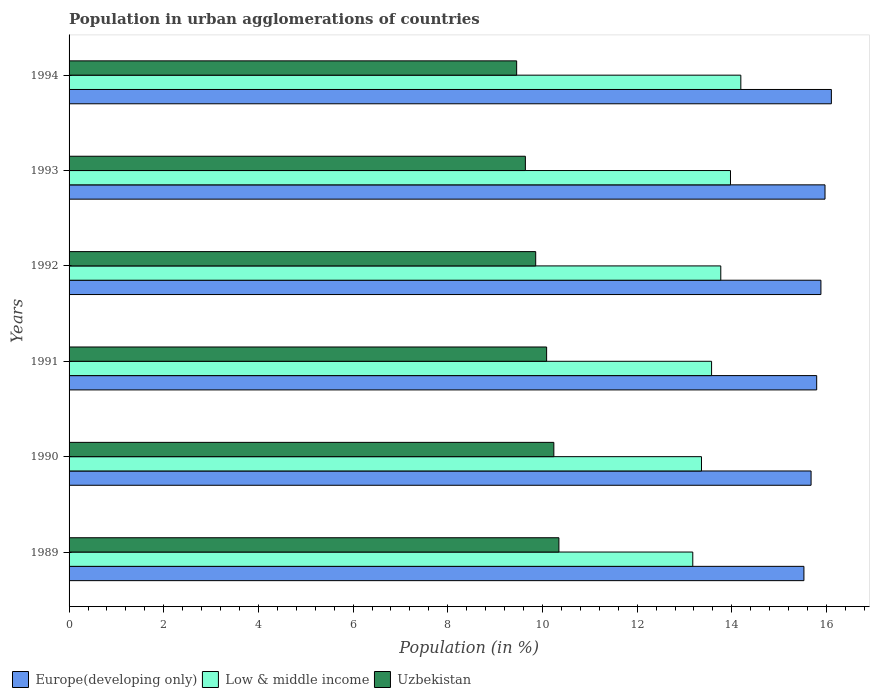How many groups of bars are there?
Your answer should be compact. 6. Are the number of bars on each tick of the Y-axis equal?
Offer a terse response. Yes. How many bars are there on the 6th tick from the top?
Offer a very short reply. 3. What is the label of the 4th group of bars from the top?
Offer a terse response. 1991. In how many cases, is the number of bars for a given year not equal to the number of legend labels?
Your answer should be very brief. 0. What is the percentage of population in urban agglomerations in Uzbekistan in 1992?
Offer a terse response. 9.86. Across all years, what is the maximum percentage of population in urban agglomerations in Low & middle income?
Offer a very short reply. 14.19. Across all years, what is the minimum percentage of population in urban agglomerations in Uzbekistan?
Ensure brevity in your answer.  9.46. In which year was the percentage of population in urban agglomerations in Europe(developing only) minimum?
Your answer should be compact. 1989. What is the total percentage of population in urban agglomerations in Uzbekistan in the graph?
Keep it short and to the point. 59.63. What is the difference between the percentage of population in urban agglomerations in Europe(developing only) in 1989 and that in 1991?
Provide a short and direct response. -0.27. What is the difference between the percentage of population in urban agglomerations in Low & middle income in 1993 and the percentage of population in urban agglomerations in Europe(developing only) in 1994?
Your answer should be very brief. -2.13. What is the average percentage of population in urban agglomerations in Low & middle income per year?
Your response must be concise. 13.67. In the year 1993, what is the difference between the percentage of population in urban agglomerations in Europe(developing only) and percentage of population in urban agglomerations in Uzbekistan?
Provide a succinct answer. 6.33. What is the ratio of the percentage of population in urban agglomerations in Europe(developing only) in 1989 to that in 1991?
Your answer should be compact. 0.98. Is the difference between the percentage of population in urban agglomerations in Europe(developing only) in 1991 and 1993 greater than the difference between the percentage of population in urban agglomerations in Uzbekistan in 1991 and 1993?
Your answer should be very brief. No. What is the difference between the highest and the second highest percentage of population in urban agglomerations in Uzbekistan?
Make the answer very short. 0.11. What is the difference between the highest and the lowest percentage of population in urban agglomerations in Uzbekistan?
Offer a terse response. 0.89. What does the 3rd bar from the top in 1993 represents?
Offer a very short reply. Europe(developing only). What does the 1st bar from the bottom in 1990 represents?
Provide a short and direct response. Europe(developing only). How many bars are there?
Provide a short and direct response. 18. Are all the bars in the graph horizontal?
Your response must be concise. Yes. How many years are there in the graph?
Provide a short and direct response. 6. What is the difference between two consecutive major ticks on the X-axis?
Offer a very short reply. 2. Are the values on the major ticks of X-axis written in scientific E-notation?
Offer a terse response. No. Does the graph contain any zero values?
Your response must be concise. No. How many legend labels are there?
Your answer should be compact. 3. How are the legend labels stacked?
Offer a terse response. Horizontal. What is the title of the graph?
Keep it short and to the point. Population in urban agglomerations of countries. Does "Sao Tome and Principe" appear as one of the legend labels in the graph?
Make the answer very short. No. What is the label or title of the X-axis?
Make the answer very short. Population (in %). What is the Population (in %) in Europe(developing only) in 1989?
Provide a short and direct response. 15.52. What is the Population (in %) of Low & middle income in 1989?
Offer a very short reply. 13.18. What is the Population (in %) in Uzbekistan in 1989?
Give a very brief answer. 10.35. What is the Population (in %) of Europe(developing only) in 1990?
Your response must be concise. 15.67. What is the Population (in %) in Low & middle income in 1990?
Give a very brief answer. 13.36. What is the Population (in %) in Uzbekistan in 1990?
Provide a short and direct response. 10.24. What is the Population (in %) of Europe(developing only) in 1991?
Offer a very short reply. 15.79. What is the Population (in %) in Low & middle income in 1991?
Give a very brief answer. 13.57. What is the Population (in %) of Uzbekistan in 1991?
Provide a short and direct response. 10.09. What is the Population (in %) of Europe(developing only) in 1992?
Offer a terse response. 15.88. What is the Population (in %) of Low & middle income in 1992?
Your answer should be very brief. 13.77. What is the Population (in %) in Uzbekistan in 1992?
Your answer should be compact. 9.86. What is the Population (in %) of Europe(developing only) in 1993?
Your response must be concise. 15.97. What is the Population (in %) of Low & middle income in 1993?
Give a very brief answer. 13.97. What is the Population (in %) of Uzbekistan in 1993?
Provide a short and direct response. 9.64. What is the Population (in %) in Europe(developing only) in 1994?
Ensure brevity in your answer.  16.1. What is the Population (in %) of Low & middle income in 1994?
Your answer should be very brief. 14.19. What is the Population (in %) of Uzbekistan in 1994?
Your answer should be compact. 9.46. Across all years, what is the maximum Population (in %) of Europe(developing only)?
Offer a very short reply. 16.1. Across all years, what is the maximum Population (in %) in Low & middle income?
Provide a succinct answer. 14.19. Across all years, what is the maximum Population (in %) of Uzbekistan?
Make the answer very short. 10.35. Across all years, what is the minimum Population (in %) of Europe(developing only)?
Offer a terse response. 15.52. Across all years, what is the minimum Population (in %) of Low & middle income?
Ensure brevity in your answer.  13.18. Across all years, what is the minimum Population (in %) of Uzbekistan?
Your response must be concise. 9.46. What is the total Population (in %) in Europe(developing only) in the graph?
Provide a short and direct response. 94.95. What is the total Population (in %) of Low & middle income in the graph?
Give a very brief answer. 82.04. What is the total Population (in %) in Uzbekistan in the graph?
Offer a terse response. 59.63. What is the difference between the Population (in %) of Europe(developing only) in 1989 and that in 1990?
Provide a short and direct response. -0.15. What is the difference between the Population (in %) of Low & middle income in 1989 and that in 1990?
Make the answer very short. -0.18. What is the difference between the Population (in %) of Uzbekistan in 1989 and that in 1990?
Provide a succinct answer. 0.11. What is the difference between the Population (in %) in Europe(developing only) in 1989 and that in 1991?
Your response must be concise. -0.27. What is the difference between the Population (in %) of Low & middle income in 1989 and that in 1991?
Ensure brevity in your answer.  -0.4. What is the difference between the Population (in %) of Uzbekistan in 1989 and that in 1991?
Offer a terse response. 0.26. What is the difference between the Population (in %) of Europe(developing only) in 1989 and that in 1992?
Provide a short and direct response. -0.36. What is the difference between the Population (in %) of Low & middle income in 1989 and that in 1992?
Offer a terse response. -0.59. What is the difference between the Population (in %) in Uzbekistan in 1989 and that in 1992?
Your answer should be compact. 0.49. What is the difference between the Population (in %) of Europe(developing only) in 1989 and that in 1993?
Give a very brief answer. -0.45. What is the difference between the Population (in %) of Low & middle income in 1989 and that in 1993?
Give a very brief answer. -0.8. What is the difference between the Population (in %) in Uzbekistan in 1989 and that in 1993?
Your answer should be very brief. 0.71. What is the difference between the Population (in %) of Europe(developing only) in 1989 and that in 1994?
Your response must be concise. -0.58. What is the difference between the Population (in %) in Low & middle income in 1989 and that in 1994?
Offer a terse response. -1.01. What is the difference between the Population (in %) in Uzbekistan in 1989 and that in 1994?
Keep it short and to the point. 0.89. What is the difference between the Population (in %) in Europe(developing only) in 1990 and that in 1991?
Give a very brief answer. -0.12. What is the difference between the Population (in %) in Low & middle income in 1990 and that in 1991?
Offer a very short reply. -0.21. What is the difference between the Population (in %) in Uzbekistan in 1990 and that in 1991?
Make the answer very short. 0.15. What is the difference between the Population (in %) of Europe(developing only) in 1990 and that in 1992?
Keep it short and to the point. -0.21. What is the difference between the Population (in %) of Low & middle income in 1990 and that in 1992?
Your answer should be compact. -0.41. What is the difference between the Population (in %) in Uzbekistan in 1990 and that in 1992?
Your answer should be compact. 0.38. What is the difference between the Population (in %) in Europe(developing only) in 1990 and that in 1993?
Your answer should be compact. -0.29. What is the difference between the Population (in %) of Low & middle income in 1990 and that in 1993?
Give a very brief answer. -0.61. What is the difference between the Population (in %) in Uzbekistan in 1990 and that in 1993?
Offer a very short reply. 0.6. What is the difference between the Population (in %) in Europe(developing only) in 1990 and that in 1994?
Your answer should be very brief. -0.43. What is the difference between the Population (in %) in Low & middle income in 1990 and that in 1994?
Your answer should be very brief. -0.83. What is the difference between the Population (in %) of Uzbekistan in 1990 and that in 1994?
Your answer should be compact. 0.79. What is the difference between the Population (in %) in Europe(developing only) in 1991 and that in 1992?
Offer a very short reply. -0.09. What is the difference between the Population (in %) in Low & middle income in 1991 and that in 1992?
Ensure brevity in your answer.  -0.19. What is the difference between the Population (in %) in Uzbekistan in 1991 and that in 1992?
Keep it short and to the point. 0.23. What is the difference between the Population (in %) of Europe(developing only) in 1991 and that in 1993?
Keep it short and to the point. -0.18. What is the difference between the Population (in %) of Low & middle income in 1991 and that in 1993?
Provide a succinct answer. -0.4. What is the difference between the Population (in %) of Uzbekistan in 1991 and that in 1993?
Keep it short and to the point. 0.45. What is the difference between the Population (in %) in Europe(developing only) in 1991 and that in 1994?
Your answer should be compact. -0.31. What is the difference between the Population (in %) of Low & middle income in 1991 and that in 1994?
Provide a succinct answer. -0.62. What is the difference between the Population (in %) of Uzbekistan in 1991 and that in 1994?
Make the answer very short. 0.63. What is the difference between the Population (in %) of Europe(developing only) in 1992 and that in 1993?
Give a very brief answer. -0.09. What is the difference between the Population (in %) in Low & middle income in 1992 and that in 1993?
Provide a short and direct response. -0.2. What is the difference between the Population (in %) of Uzbekistan in 1992 and that in 1993?
Offer a very short reply. 0.22. What is the difference between the Population (in %) in Europe(developing only) in 1992 and that in 1994?
Keep it short and to the point. -0.22. What is the difference between the Population (in %) in Low & middle income in 1992 and that in 1994?
Offer a terse response. -0.42. What is the difference between the Population (in %) of Uzbekistan in 1992 and that in 1994?
Your answer should be very brief. 0.4. What is the difference between the Population (in %) in Europe(developing only) in 1993 and that in 1994?
Offer a very short reply. -0.13. What is the difference between the Population (in %) of Low & middle income in 1993 and that in 1994?
Offer a terse response. -0.22. What is the difference between the Population (in %) in Uzbekistan in 1993 and that in 1994?
Provide a succinct answer. 0.18. What is the difference between the Population (in %) in Europe(developing only) in 1989 and the Population (in %) in Low & middle income in 1990?
Provide a succinct answer. 2.16. What is the difference between the Population (in %) in Europe(developing only) in 1989 and the Population (in %) in Uzbekistan in 1990?
Keep it short and to the point. 5.28. What is the difference between the Population (in %) in Low & middle income in 1989 and the Population (in %) in Uzbekistan in 1990?
Your answer should be very brief. 2.94. What is the difference between the Population (in %) of Europe(developing only) in 1989 and the Population (in %) of Low & middle income in 1991?
Give a very brief answer. 1.95. What is the difference between the Population (in %) in Europe(developing only) in 1989 and the Population (in %) in Uzbekistan in 1991?
Provide a succinct answer. 5.44. What is the difference between the Population (in %) in Low & middle income in 1989 and the Population (in %) in Uzbekistan in 1991?
Offer a terse response. 3.09. What is the difference between the Population (in %) of Europe(developing only) in 1989 and the Population (in %) of Low & middle income in 1992?
Provide a short and direct response. 1.76. What is the difference between the Population (in %) in Europe(developing only) in 1989 and the Population (in %) in Uzbekistan in 1992?
Give a very brief answer. 5.67. What is the difference between the Population (in %) of Low & middle income in 1989 and the Population (in %) of Uzbekistan in 1992?
Keep it short and to the point. 3.32. What is the difference between the Population (in %) of Europe(developing only) in 1989 and the Population (in %) of Low & middle income in 1993?
Keep it short and to the point. 1.55. What is the difference between the Population (in %) in Europe(developing only) in 1989 and the Population (in %) in Uzbekistan in 1993?
Provide a short and direct response. 5.88. What is the difference between the Population (in %) of Low & middle income in 1989 and the Population (in %) of Uzbekistan in 1993?
Your answer should be very brief. 3.54. What is the difference between the Population (in %) of Europe(developing only) in 1989 and the Population (in %) of Low & middle income in 1994?
Your answer should be compact. 1.33. What is the difference between the Population (in %) in Europe(developing only) in 1989 and the Population (in %) in Uzbekistan in 1994?
Make the answer very short. 6.07. What is the difference between the Population (in %) of Low & middle income in 1989 and the Population (in %) of Uzbekistan in 1994?
Your response must be concise. 3.72. What is the difference between the Population (in %) in Europe(developing only) in 1990 and the Population (in %) in Low & middle income in 1991?
Provide a short and direct response. 2.1. What is the difference between the Population (in %) in Europe(developing only) in 1990 and the Population (in %) in Uzbekistan in 1991?
Offer a very short reply. 5.59. What is the difference between the Population (in %) of Low & middle income in 1990 and the Population (in %) of Uzbekistan in 1991?
Provide a succinct answer. 3.27. What is the difference between the Population (in %) in Europe(developing only) in 1990 and the Population (in %) in Low & middle income in 1992?
Your answer should be very brief. 1.91. What is the difference between the Population (in %) in Europe(developing only) in 1990 and the Population (in %) in Uzbekistan in 1992?
Offer a very short reply. 5.82. What is the difference between the Population (in %) in Low & middle income in 1990 and the Population (in %) in Uzbekistan in 1992?
Provide a succinct answer. 3.5. What is the difference between the Population (in %) in Europe(developing only) in 1990 and the Population (in %) in Low & middle income in 1993?
Keep it short and to the point. 1.7. What is the difference between the Population (in %) in Europe(developing only) in 1990 and the Population (in %) in Uzbekistan in 1993?
Give a very brief answer. 6.04. What is the difference between the Population (in %) of Low & middle income in 1990 and the Population (in %) of Uzbekistan in 1993?
Ensure brevity in your answer.  3.72. What is the difference between the Population (in %) in Europe(developing only) in 1990 and the Population (in %) in Low & middle income in 1994?
Give a very brief answer. 1.48. What is the difference between the Population (in %) in Europe(developing only) in 1990 and the Population (in %) in Uzbekistan in 1994?
Offer a terse response. 6.22. What is the difference between the Population (in %) in Low & middle income in 1990 and the Population (in %) in Uzbekistan in 1994?
Offer a very short reply. 3.9. What is the difference between the Population (in %) of Europe(developing only) in 1991 and the Population (in %) of Low & middle income in 1992?
Provide a short and direct response. 2.03. What is the difference between the Population (in %) of Europe(developing only) in 1991 and the Population (in %) of Uzbekistan in 1992?
Give a very brief answer. 5.94. What is the difference between the Population (in %) in Low & middle income in 1991 and the Population (in %) in Uzbekistan in 1992?
Ensure brevity in your answer.  3.72. What is the difference between the Population (in %) of Europe(developing only) in 1991 and the Population (in %) of Low & middle income in 1993?
Ensure brevity in your answer.  1.82. What is the difference between the Population (in %) in Europe(developing only) in 1991 and the Population (in %) in Uzbekistan in 1993?
Ensure brevity in your answer.  6.15. What is the difference between the Population (in %) of Low & middle income in 1991 and the Population (in %) of Uzbekistan in 1993?
Your response must be concise. 3.93. What is the difference between the Population (in %) of Europe(developing only) in 1991 and the Population (in %) of Low & middle income in 1994?
Ensure brevity in your answer.  1.6. What is the difference between the Population (in %) in Europe(developing only) in 1991 and the Population (in %) in Uzbekistan in 1994?
Provide a short and direct response. 6.34. What is the difference between the Population (in %) of Low & middle income in 1991 and the Population (in %) of Uzbekistan in 1994?
Ensure brevity in your answer.  4.12. What is the difference between the Population (in %) in Europe(developing only) in 1992 and the Population (in %) in Low & middle income in 1993?
Give a very brief answer. 1.91. What is the difference between the Population (in %) of Europe(developing only) in 1992 and the Population (in %) of Uzbekistan in 1993?
Your answer should be compact. 6.24. What is the difference between the Population (in %) of Low & middle income in 1992 and the Population (in %) of Uzbekistan in 1993?
Your response must be concise. 4.13. What is the difference between the Population (in %) of Europe(developing only) in 1992 and the Population (in %) of Low & middle income in 1994?
Make the answer very short. 1.69. What is the difference between the Population (in %) of Europe(developing only) in 1992 and the Population (in %) of Uzbekistan in 1994?
Offer a terse response. 6.43. What is the difference between the Population (in %) of Low & middle income in 1992 and the Population (in %) of Uzbekistan in 1994?
Provide a succinct answer. 4.31. What is the difference between the Population (in %) of Europe(developing only) in 1993 and the Population (in %) of Low & middle income in 1994?
Offer a terse response. 1.78. What is the difference between the Population (in %) in Europe(developing only) in 1993 and the Population (in %) in Uzbekistan in 1994?
Keep it short and to the point. 6.51. What is the difference between the Population (in %) in Low & middle income in 1993 and the Population (in %) in Uzbekistan in 1994?
Ensure brevity in your answer.  4.52. What is the average Population (in %) of Europe(developing only) per year?
Provide a short and direct response. 15.82. What is the average Population (in %) in Low & middle income per year?
Offer a very short reply. 13.67. What is the average Population (in %) in Uzbekistan per year?
Give a very brief answer. 9.94. In the year 1989, what is the difference between the Population (in %) of Europe(developing only) and Population (in %) of Low & middle income?
Your response must be concise. 2.35. In the year 1989, what is the difference between the Population (in %) in Europe(developing only) and Population (in %) in Uzbekistan?
Make the answer very short. 5.18. In the year 1989, what is the difference between the Population (in %) in Low & middle income and Population (in %) in Uzbekistan?
Provide a succinct answer. 2.83. In the year 1990, what is the difference between the Population (in %) in Europe(developing only) and Population (in %) in Low & middle income?
Keep it short and to the point. 2.32. In the year 1990, what is the difference between the Population (in %) in Europe(developing only) and Population (in %) in Uzbekistan?
Give a very brief answer. 5.43. In the year 1990, what is the difference between the Population (in %) of Low & middle income and Population (in %) of Uzbekistan?
Your response must be concise. 3.12. In the year 1991, what is the difference between the Population (in %) of Europe(developing only) and Population (in %) of Low & middle income?
Your answer should be compact. 2.22. In the year 1991, what is the difference between the Population (in %) of Europe(developing only) and Population (in %) of Uzbekistan?
Provide a short and direct response. 5.71. In the year 1991, what is the difference between the Population (in %) in Low & middle income and Population (in %) in Uzbekistan?
Your answer should be very brief. 3.48. In the year 1992, what is the difference between the Population (in %) in Europe(developing only) and Population (in %) in Low & middle income?
Offer a terse response. 2.12. In the year 1992, what is the difference between the Population (in %) of Europe(developing only) and Population (in %) of Uzbekistan?
Provide a short and direct response. 6.03. In the year 1992, what is the difference between the Population (in %) in Low & middle income and Population (in %) in Uzbekistan?
Provide a succinct answer. 3.91. In the year 1993, what is the difference between the Population (in %) of Europe(developing only) and Population (in %) of Low & middle income?
Your answer should be compact. 2. In the year 1993, what is the difference between the Population (in %) of Europe(developing only) and Population (in %) of Uzbekistan?
Give a very brief answer. 6.33. In the year 1993, what is the difference between the Population (in %) of Low & middle income and Population (in %) of Uzbekistan?
Offer a very short reply. 4.33. In the year 1994, what is the difference between the Population (in %) in Europe(developing only) and Population (in %) in Low & middle income?
Your answer should be compact. 1.91. In the year 1994, what is the difference between the Population (in %) of Europe(developing only) and Population (in %) of Uzbekistan?
Provide a short and direct response. 6.65. In the year 1994, what is the difference between the Population (in %) of Low & middle income and Population (in %) of Uzbekistan?
Provide a short and direct response. 4.74. What is the ratio of the Population (in %) of Low & middle income in 1989 to that in 1990?
Make the answer very short. 0.99. What is the ratio of the Population (in %) of Uzbekistan in 1989 to that in 1990?
Make the answer very short. 1.01. What is the ratio of the Population (in %) of Europe(developing only) in 1989 to that in 1991?
Make the answer very short. 0.98. What is the ratio of the Population (in %) in Low & middle income in 1989 to that in 1991?
Ensure brevity in your answer.  0.97. What is the ratio of the Population (in %) of Uzbekistan in 1989 to that in 1991?
Provide a short and direct response. 1.03. What is the ratio of the Population (in %) in Europe(developing only) in 1989 to that in 1992?
Your answer should be compact. 0.98. What is the ratio of the Population (in %) of Uzbekistan in 1989 to that in 1992?
Provide a short and direct response. 1.05. What is the ratio of the Population (in %) of Europe(developing only) in 1989 to that in 1993?
Provide a succinct answer. 0.97. What is the ratio of the Population (in %) in Low & middle income in 1989 to that in 1993?
Make the answer very short. 0.94. What is the ratio of the Population (in %) of Uzbekistan in 1989 to that in 1993?
Give a very brief answer. 1.07. What is the ratio of the Population (in %) of Low & middle income in 1989 to that in 1994?
Provide a short and direct response. 0.93. What is the ratio of the Population (in %) of Uzbekistan in 1989 to that in 1994?
Your answer should be very brief. 1.09. What is the ratio of the Population (in %) of Europe(developing only) in 1990 to that in 1991?
Keep it short and to the point. 0.99. What is the ratio of the Population (in %) of Low & middle income in 1990 to that in 1991?
Ensure brevity in your answer.  0.98. What is the ratio of the Population (in %) of Uzbekistan in 1990 to that in 1991?
Make the answer very short. 1.02. What is the ratio of the Population (in %) in Europe(developing only) in 1990 to that in 1992?
Keep it short and to the point. 0.99. What is the ratio of the Population (in %) in Low & middle income in 1990 to that in 1992?
Ensure brevity in your answer.  0.97. What is the ratio of the Population (in %) of Uzbekistan in 1990 to that in 1992?
Ensure brevity in your answer.  1.04. What is the ratio of the Population (in %) of Europe(developing only) in 1990 to that in 1993?
Make the answer very short. 0.98. What is the ratio of the Population (in %) in Low & middle income in 1990 to that in 1993?
Provide a succinct answer. 0.96. What is the ratio of the Population (in %) of Uzbekistan in 1990 to that in 1993?
Offer a very short reply. 1.06. What is the ratio of the Population (in %) in Europe(developing only) in 1990 to that in 1994?
Your answer should be compact. 0.97. What is the ratio of the Population (in %) in Low & middle income in 1990 to that in 1994?
Your answer should be very brief. 0.94. What is the ratio of the Population (in %) of Uzbekistan in 1990 to that in 1994?
Offer a terse response. 1.08. What is the ratio of the Population (in %) of Low & middle income in 1991 to that in 1992?
Make the answer very short. 0.99. What is the ratio of the Population (in %) in Uzbekistan in 1991 to that in 1992?
Keep it short and to the point. 1.02. What is the ratio of the Population (in %) in Low & middle income in 1991 to that in 1993?
Your answer should be very brief. 0.97. What is the ratio of the Population (in %) in Uzbekistan in 1991 to that in 1993?
Make the answer very short. 1.05. What is the ratio of the Population (in %) in Europe(developing only) in 1991 to that in 1994?
Your answer should be very brief. 0.98. What is the ratio of the Population (in %) of Low & middle income in 1991 to that in 1994?
Offer a very short reply. 0.96. What is the ratio of the Population (in %) of Uzbekistan in 1991 to that in 1994?
Your answer should be compact. 1.07. What is the ratio of the Population (in %) in Uzbekistan in 1992 to that in 1993?
Keep it short and to the point. 1.02. What is the ratio of the Population (in %) in Europe(developing only) in 1992 to that in 1994?
Your response must be concise. 0.99. What is the ratio of the Population (in %) of Low & middle income in 1992 to that in 1994?
Your answer should be very brief. 0.97. What is the ratio of the Population (in %) in Uzbekistan in 1992 to that in 1994?
Your answer should be compact. 1.04. What is the ratio of the Population (in %) of Europe(developing only) in 1993 to that in 1994?
Provide a short and direct response. 0.99. What is the ratio of the Population (in %) of Low & middle income in 1993 to that in 1994?
Your response must be concise. 0.98. What is the ratio of the Population (in %) in Uzbekistan in 1993 to that in 1994?
Keep it short and to the point. 1.02. What is the difference between the highest and the second highest Population (in %) in Europe(developing only)?
Your answer should be very brief. 0.13. What is the difference between the highest and the second highest Population (in %) in Low & middle income?
Offer a terse response. 0.22. What is the difference between the highest and the second highest Population (in %) in Uzbekistan?
Give a very brief answer. 0.11. What is the difference between the highest and the lowest Population (in %) in Europe(developing only)?
Your answer should be very brief. 0.58. What is the difference between the highest and the lowest Population (in %) in Low & middle income?
Your response must be concise. 1.01. What is the difference between the highest and the lowest Population (in %) in Uzbekistan?
Offer a terse response. 0.89. 